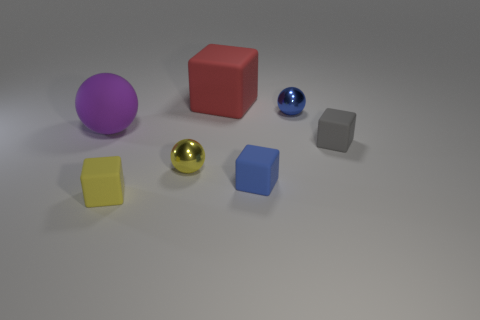Subtract all gray cubes. Subtract all yellow cylinders. How many cubes are left? 3 Add 2 small metallic spheres. How many objects exist? 9 Subtract all blocks. How many objects are left? 3 Add 1 yellow things. How many yellow things exist? 3 Subtract 0 brown cylinders. How many objects are left? 7 Subtract all large cubes. Subtract all tiny blue things. How many objects are left? 4 Add 4 large matte spheres. How many large matte spheres are left? 5 